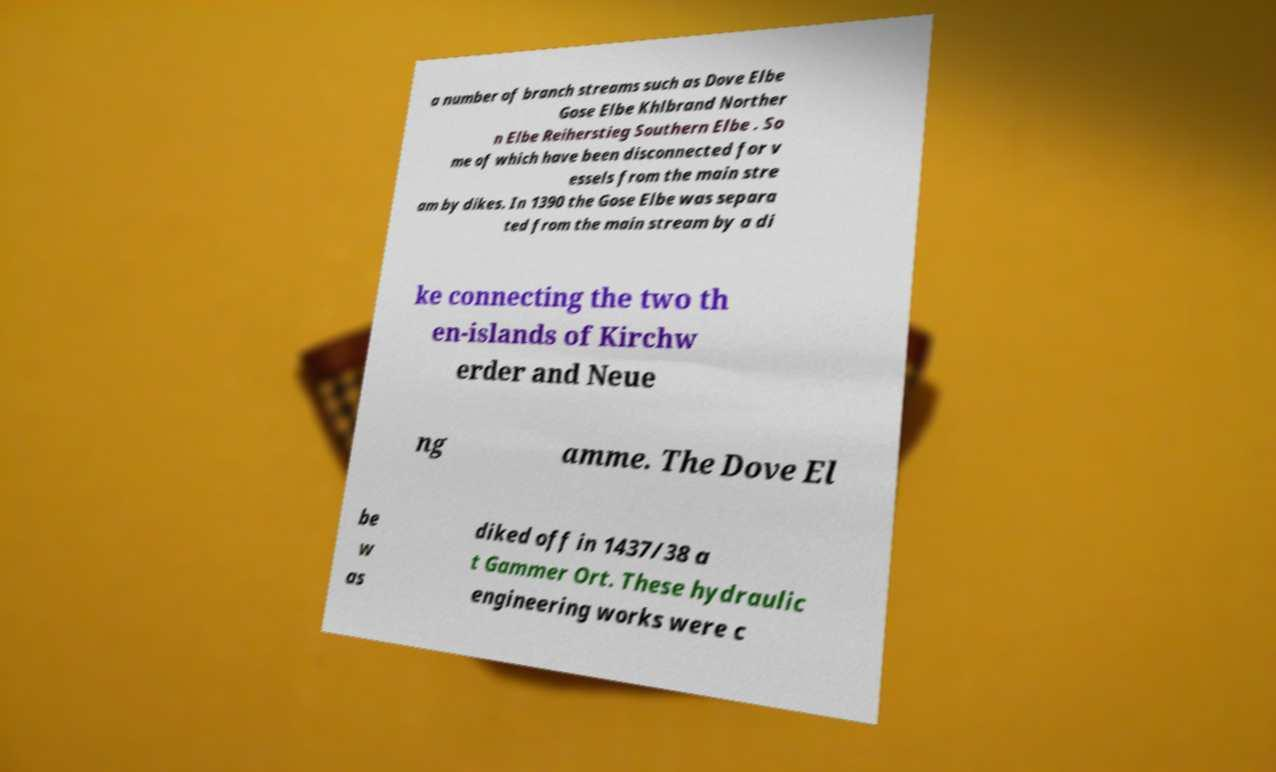What messages or text are displayed in this image? I need them in a readable, typed format. a number of branch streams such as Dove Elbe Gose Elbe Khlbrand Norther n Elbe Reiherstieg Southern Elbe . So me of which have been disconnected for v essels from the main stre am by dikes. In 1390 the Gose Elbe was separa ted from the main stream by a di ke connecting the two th en-islands of Kirchw erder and Neue ng amme. The Dove El be w as diked off in 1437/38 a t Gammer Ort. These hydraulic engineering works were c 